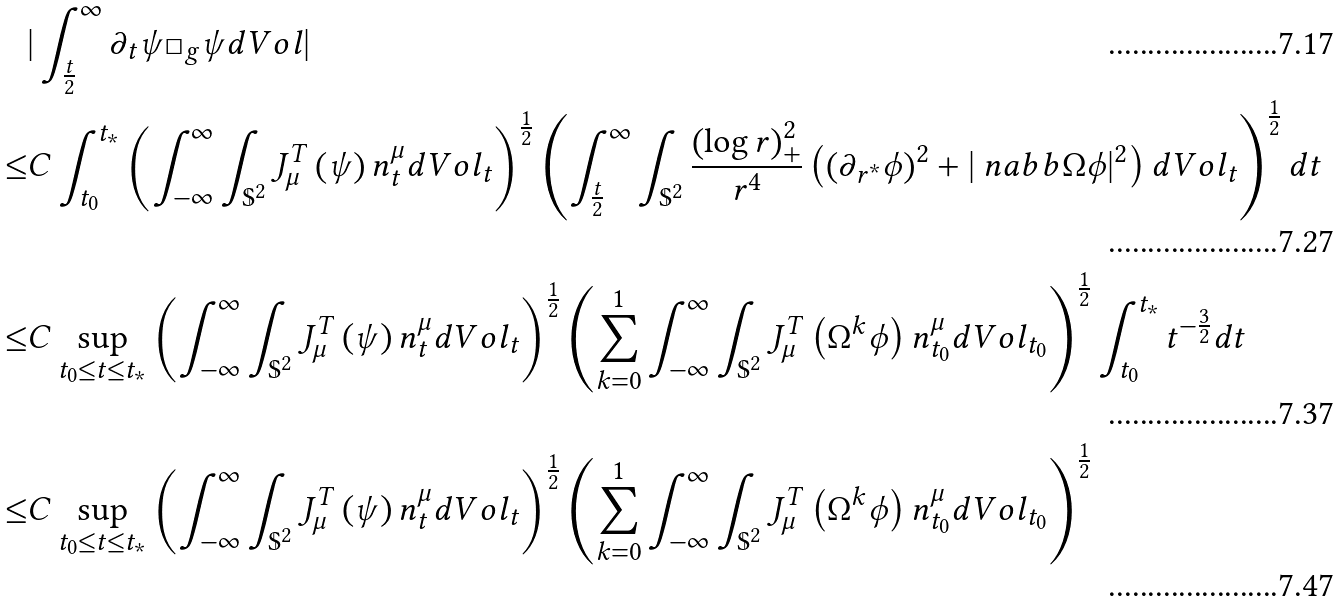<formula> <loc_0><loc_0><loc_500><loc_500>& | \int _ { \frac { t } { 2 } } ^ { \infty } \partial _ { t } \psi \Box _ { g } \psi d V o l | \\ \leq & C \int _ { t _ { 0 } } ^ { t _ { * } } \left ( \int _ { - \infty } ^ { \infty } \int _ { \mathbb { S } ^ { 2 } } J ^ { T } _ { \mu } \left ( \psi \right ) n ^ { \mu } _ { t } d V o l _ { t } \right ) ^ { \frac { 1 } { 2 } } \left ( \int _ { \frac { t } { 2 } } ^ { \infty } \int _ { \mathbb { S } ^ { 2 } } \frac { \left ( \log r \right ) _ { + } ^ { 2 } } { r ^ { 4 } } \left ( \left ( \partial _ { r ^ { * } } \phi \right ) ^ { 2 } + | \ n a b b \Omega \phi | ^ { 2 } \right ) d V o l _ { t } \right ) ^ { \frac { 1 } { 2 } } d t \\ \leq & C \sup _ { t _ { 0 } \leq t \leq t _ { * } } \left ( \int _ { - \infty } ^ { \infty } \int _ { \mathbb { S } ^ { 2 } } J ^ { T } _ { \mu } \left ( \psi \right ) n ^ { \mu } _ { t } d V o l _ { t } \right ) ^ { \frac { 1 } { 2 } } \left ( \sum _ { k = 0 } ^ { 1 } \int _ { - \infty } ^ { \infty } \int _ { \mathbb { S } ^ { 2 } } J ^ { T } _ { \mu } \left ( \Omega ^ { k } \phi \right ) n ^ { \mu } _ { t _ { 0 } } d V o l _ { t _ { 0 } } \right ) ^ { \frac { 1 } { 2 } } \int _ { t _ { 0 } } ^ { t _ { * } } t ^ { - \frac { 3 } { 2 } } d t \\ \leq & C \sup _ { t _ { 0 } \leq t \leq t _ { * } } \left ( \int _ { - \infty } ^ { \infty } \int _ { \mathbb { S } ^ { 2 } } J ^ { T } _ { \mu } \left ( \psi \right ) n ^ { \mu } _ { t } d V o l _ { t } \right ) ^ { \frac { 1 } { 2 } } \left ( \sum _ { k = 0 } ^ { 1 } \int _ { - \infty } ^ { \infty } \int _ { \mathbb { S } ^ { 2 } } J ^ { T } _ { \mu } \left ( \Omega ^ { k } \phi \right ) n ^ { \mu } _ { t _ { 0 } } d V o l _ { t _ { 0 } } \right ) ^ { \frac { 1 } { 2 } }</formula> 